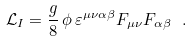Convert formula to latex. <formula><loc_0><loc_0><loc_500><loc_500>\mathcal { L } _ { I } = \frac { g } { 8 } \, \phi \, \varepsilon ^ { \mu \nu \alpha \beta } F _ { \mu \nu } F _ { \alpha \beta } \ .</formula> 